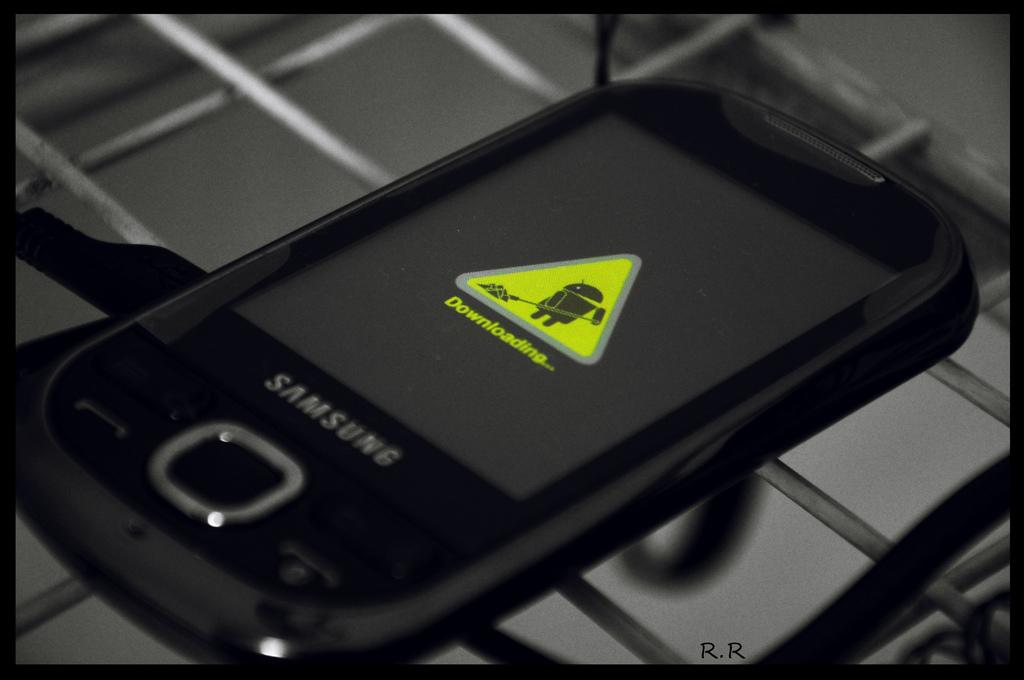<image>
Create a compact narrative representing the image presented. The front screen of a samsung branded phone downloading an update. 